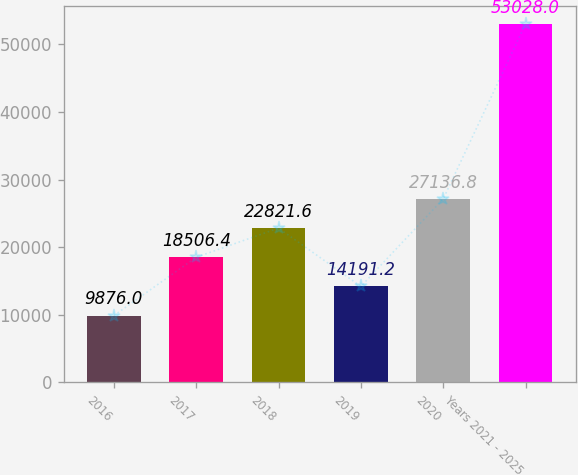Convert chart to OTSL. <chart><loc_0><loc_0><loc_500><loc_500><bar_chart><fcel>2016<fcel>2017<fcel>2018<fcel>2019<fcel>2020<fcel>Years 2021 - 2025<nl><fcel>9876<fcel>18506.4<fcel>22821.6<fcel>14191.2<fcel>27136.8<fcel>53028<nl></chart> 